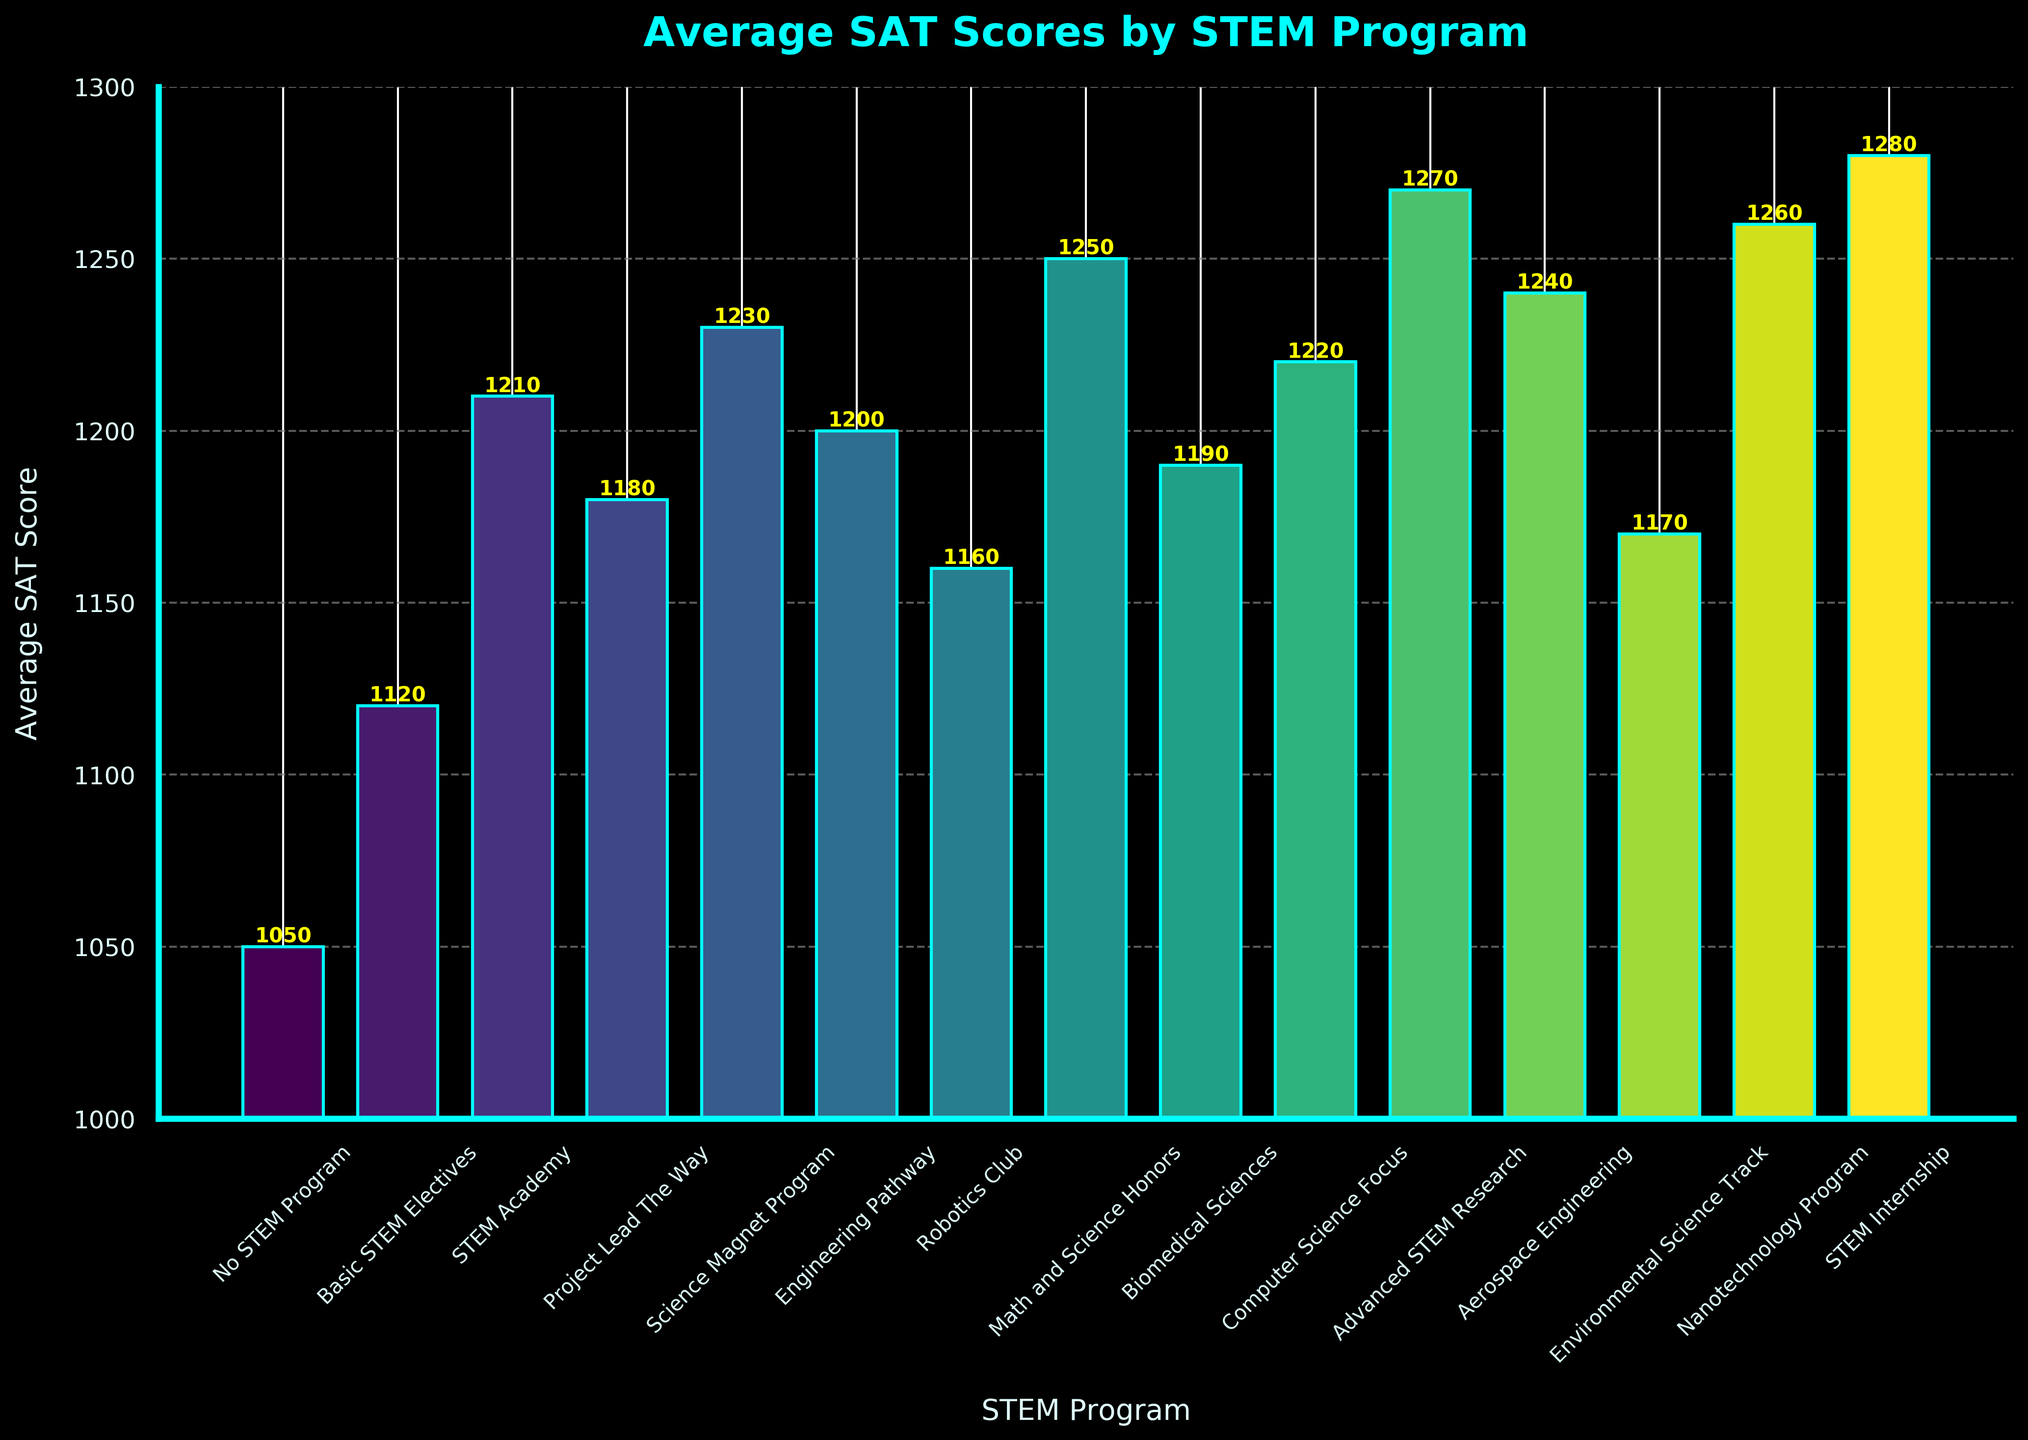Which STEM program has the highest Average SAT Score? The highest bar on the chart represents the STEM Internship program with an SAT score of 1280
Answer: STEM Internship Which STEM program has the lowest Average SAT Score? The lowest bar on the chart represents the No STEM Program with an SAT score of 1050
Answer: No STEM Program What is the difference in Average SAT Scores between the STEM Internship and the No STEM Program? The average SAT score for the STEM Internship is 1280, and for No STEM Program, it is 1050. The difference is 1280 - 1050
Answer: 230 How many STEM programs have an Average SAT Score greater than or equal to 1250? The bars representing Math and Science Honors, Aerospace Engineering, Nanotechnology Program, and STEM Internship show SAT scores of 1250, 1240, 1260, and 1280 respectively. Only Math and Science Honors, Nanotechnology Program, and STEM Internship have scores >= 1250
Answer: 3 What is the average SAT score for STEM programs focusing on engineering (Engineering Pathway, Aerospace Engineering)? The average SAT scores for Engineering Pathway and Aerospace Engineering are 1200 and 1240. The average is (1200 + 1240) / 2
Answer: 1220 Which program has a higher average SAT score: Biomedical Sciences or Computer Science Focus? The average SAT score for Biomedical Sciences is 1190, and for Computer Science Focus, it is 1220. The higher score is 1220 for Computer Science Focus
Answer: Computer Science Focus Are there any programs with an Average SAT Score of 1150? No bar in the chart represents a value of 1150
Answer: No How does the average SAT score for Science Magnet Program compare to Advanced STEM Research? The average SAT score for Science Magnet Program is 1230, while for Advanced STEM Research it is 1270. Advanced STEM Research has a higher score
Answer: Advanced STEM Research What's the median average SAT score across all STEM programs? Sorting the scores in ascending order: 1050, 1120, 1160, 1170, 1180, 1190, 1200, 1210, 1220, 1230, 1240, 1250, 1260, 1270, 1280. The middle value (8th score) is 1210
Answer: 1210 Which programs have an average SAT score between 1100 and 1200? The bars indicating values between 1100 and 1200 represent Basic STEM Electives, Robotics Club, Environmental Science Track, Biomedical Sciences, Engineering Pathway, and Project Lead The Way
Answer: Basic STEM Electives, Robotics Club, Environmental Science Track, Biomedical Sciences, Engineering Pathway, Project Lead The Way 